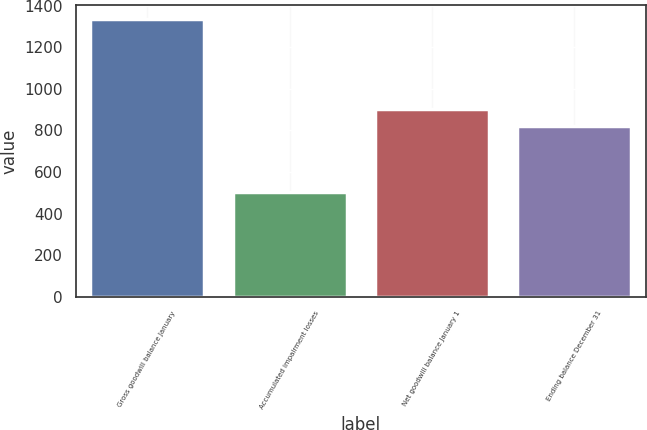Convert chart to OTSL. <chart><loc_0><loc_0><loc_500><loc_500><bar_chart><fcel>Gross goodwill balance January<fcel>Accumulated impairment losses<fcel>Net goodwill balance January 1<fcel>Ending balance December 31<nl><fcel>1334.7<fcel>501.8<fcel>905.59<fcel>822.3<nl></chart> 